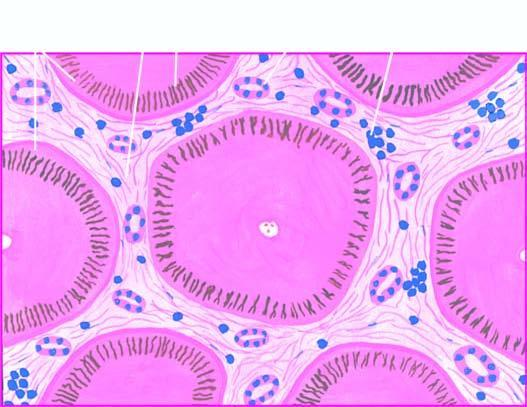what contain elongated bile plugs?
Answer the question using a single word or phrase. Many of the hepatocytes 